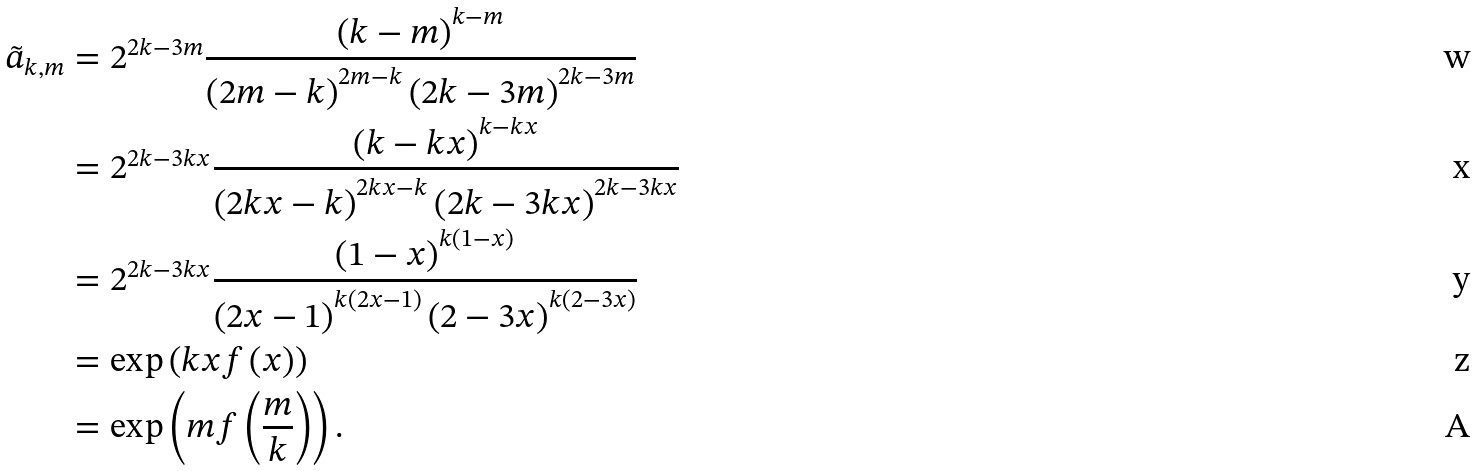<formula> <loc_0><loc_0><loc_500><loc_500>\tilde { a } _ { k , m } & = 2 ^ { 2 k - 3 m } \frac { \left ( k - m \right ) ^ { k - m } } { \left ( 2 m - k \right ) ^ { 2 m - k } \left ( 2 k - 3 m \right ) ^ { 2 k - 3 m } } \\ & = 2 ^ { 2 k - 3 k x } \frac { \left ( k - k x \right ) ^ { k - k x } } { \left ( 2 k x - k \right ) ^ { 2 k x - k } \left ( 2 k - 3 k x \right ) ^ { 2 k - 3 k x } } \\ & = 2 ^ { 2 k - 3 k x } \frac { \left ( 1 - x \right ) ^ { k ( 1 - x ) } } { \left ( 2 x - 1 \right ) ^ { k ( 2 x - 1 ) } \left ( 2 - 3 x \right ) ^ { k ( 2 - 3 x ) } } \\ & = \exp \left ( k x f \left ( x \right ) \right ) \\ & = \exp \left ( m f \left ( \frac { m } { k } \right ) \right ) .</formula> 